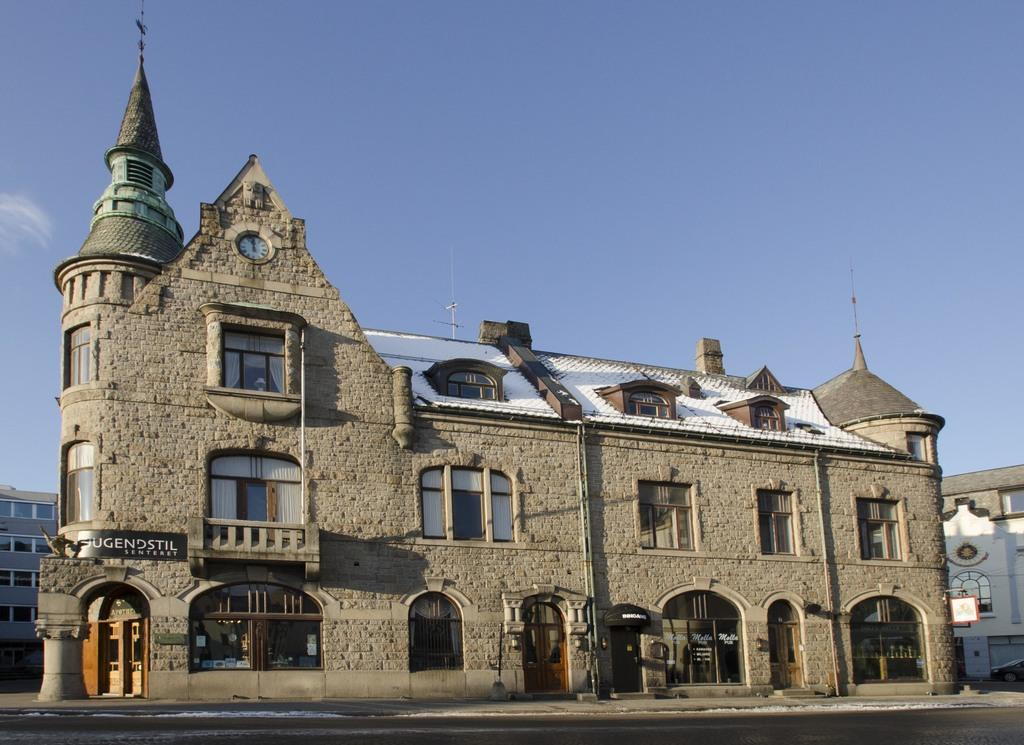What is located in the center of the image? There are buildings in the center of the image. What features do the buildings have? The buildings have windows, doors, and roofs. What other objects are present in the center of the image? There are boards, a clock, and poles in the center of the image. What is visible at the bottom of the image? There is a road at the bottom of the image. What is visible at the top of the image? There is a sky visible at the top of the image. What account number is associated with the war depicted in the image? There is no war depicted in the image, and therefore no account number can be associated with it. 